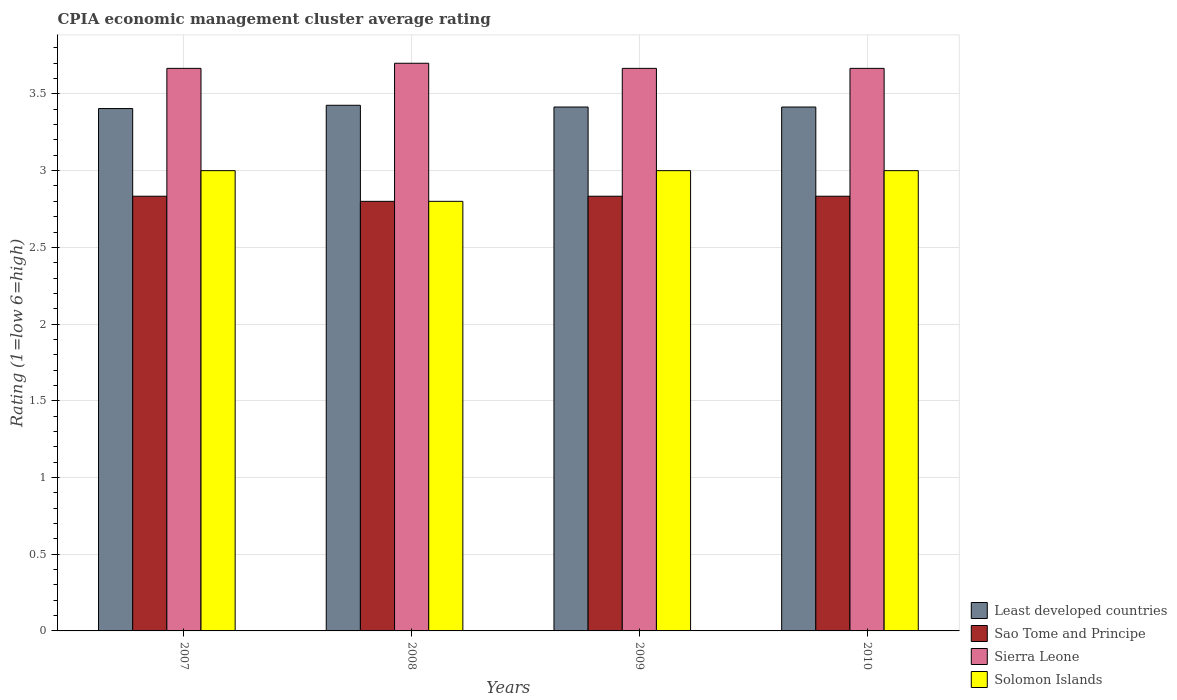Are the number of bars on each tick of the X-axis equal?
Offer a terse response. Yes. How many bars are there on the 3rd tick from the left?
Provide a succinct answer. 4. What is the label of the 1st group of bars from the left?
Ensure brevity in your answer.  2007. What is the CPIA rating in Solomon Islands in 2008?
Your answer should be very brief. 2.8. Across all years, what is the maximum CPIA rating in Solomon Islands?
Keep it short and to the point. 3. Across all years, what is the minimum CPIA rating in Sierra Leone?
Keep it short and to the point. 3.67. What is the total CPIA rating in Solomon Islands in the graph?
Your answer should be very brief. 11.8. What is the difference between the CPIA rating in Solomon Islands in 2008 and that in 2009?
Give a very brief answer. -0.2. What is the difference between the CPIA rating in Sierra Leone in 2008 and the CPIA rating in Solomon Islands in 2009?
Offer a very short reply. 0.7. What is the average CPIA rating in Solomon Islands per year?
Offer a terse response. 2.95. In the year 2007, what is the difference between the CPIA rating in Least developed countries and CPIA rating in Solomon Islands?
Make the answer very short. 0.4. What is the ratio of the CPIA rating in Least developed countries in 2007 to that in 2010?
Your response must be concise. 1. Is the CPIA rating in Sao Tome and Principe in 2009 less than that in 2010?
Give a very brief answer. No. What is the difference between the highest and the second highest CPIA rating in Sao Tome and Principe?
Offer a terse response. 0. What is the difference between the highest and the lowest CPIA rating in Solomon Islands?
Make the answer very short. 0.2. In how many years, is the CPIA rating in Sierra Leone greater than the average CPIA rating in Sierra Leone taken over all years?
Give a very brief answer. 1. Is the sum of the CPIA rating in Sierra Leone in 2008 and 2009 greater than the maximum CPIA rating in Least developed countries across all years?
Give a very brief answer. Yes. Is it the case that in every year, the sum of the CPIA rating in Sierra Leone and CPIA rating in Solomon Islands is greater than the sum of CPIA rating in Least developed countries and CPIA rating in Sao Tome and Principe?
Your answer should be compact. Yes. What does the 2nd bar from the left in 2008 represents?
Provide a succinct answer. Sao Tome and Principe. What does the 2nd bar from the right in 2008 represents?
Offer a very short reply. Sierra Leone. Is it the case that in every year, the sum of the CPIA rating in Solomon Islands and CPIA rating in Least developed countries is greater than the CPIA rating in Sao Tome and Principe?
Provide a short and direct response. Yes. What is the difference between two consecutive major ticks on the Y-axis?
Offer a terse response. 0.5. Does the graph contain any zero values?
Offer a very short reply. No. Does the graph contain grids?
Ensure brevity in your answer.  Yes. Where does the legend appear in the graph?
Your answer should be very brief. Bottom right. How are the legend labels stacked?
Offer a terse response. Vertical. What is the title of the graph?
Your response must be concise. CPIA economic management cluster average rating. What is the Rating (1=low 6=high) in Least developed countries in 2007?
Keep it short and to the point. 3.4. What is the Rating (1=low 6=high) in Sao Tome and Principe in 2007?
Provide a short and direct response. 2.83. What is the Rating (1=low 6=high) of Sierra Leone in 2007?
Make the answer very short. 3.67. What is the Rating (1=low 6=high) of Least developed countries in 2008?
Keep it short and to the point. 3.43. What is the Rating (1=low 6=high) in Sao Tome and Principe in 2008?
Give a very brief answer. 2.8. What is the Rating (1=low 6=high) of Least developed countries in 2009?
Keep it short and to the point. 3.41. What is the Rating (1=low 6=high) in Sao Tome and Principe in 2009?
Your response must be concise. 2.83. What is the Rating (1=low 6=high) in Sierra Leone in 2009?
Ensure brevity in your answer.  3.67. What is the Rating (1=low 6=high) of Least developed countries in 2010?
Your answer should be very brief. 3.41. What is the Rating (1=low 6=high) in Sao Tome and Principe in 2010?
Give a very brief answer. 2.83. What is the Rating (1=low 6=high) of Sierra Leone in 2010?
Your answer should be compact. 3.67. What is the Rating (1=low 6=high) in Solomon Islands in 2010?
Make the answer very short. 3. Across all years, what is the maximum Rating (1=low 6=high) of Least developed countries?
Provide a succinct answer. 3.43. Across all years, what is the maximum Rating (1=low 6=high) of Sao Tome and Principe?
Your answer should be compact. 2.83. Across all years, what is the maximum Rating (1=low 6=high) of Sierra Leone?
Give a very brief answer. 3.7. Across all years, what is the minimum Rating (1=low 6=high) in Least developed countries?
Ensure brevity in your answer.  3.4. Across all years, what is the minimum Rating (1=low 6=high) of Sierra Leone?
Give a very brief answer. 3.67. Across all years, what is the minimum Rating (1=low 6=high) of Solomon Islands?
Ensure brevity in your answer.  2.8. What is the total Rating (1=low 6=high) of Least developed countries in the graph?
Ensure brevity in your answer.  13.66. What is the total Rating (1=low 6=high) of Sao Tome and Principe in the graph?
Ensure brevity in your answer.  11.3. What is the total Rating (1=low 6=high) of Solomon Islands in the graph?
Your answer should be very brief. 11.8. What is the difference between the Rating (1=low 6=high) in Least developed countries in 2007 and that in 2008?
Offer a terse response. -0.02. What is the difference between the Rating (1=low 6=high) of Sierra Leone in 2007 and that in 2008?
Provide a succinct answer. -0.03. What is the difference between the Rating (1=low 6=high) in Least developed countries in 2007 and that in 2009?
Give a very brief answer. -0.01. What is the difference between the Rating (1=low 6=high) in Sao Tome and Principe in 2007 and that in 2009?
Your answer should be compact. 0. What is the difference between the Rating (1=low 6=high) in Solomon Islands in 2007 and that in 2009?
Ensure brevity in your answer.  0. What is the difference between the Rating (1=low 6=high) of Least developed countries in 2007 and that in 2010?
Give a very brief answer. -0.01. What is the difference between the Rating (1=low 6=high) of Sao Tome and Principe in 2007 and that in 2010?
Provide a short and direct response. 0. What is the difference between the Rating (1=low 6=high) of Solomon Islands in 2007 and that in 2010?
Offer a very short reply. 0. What is the difference between the Rating (1=low 6=high) of Least developed countries in 2008 and that in 2009?
Your answer should be very brief. 0.01. What is the difference between the Rating (1=low 6=high) in Sao Tome and Principe in 2008 and that in 2009?
Keep it short and to the point. -0.03. What is the difference between the Rating (1=low 6=high) of Solomon Islands in 2008 and that in 2009?
Provide a short and direct response. -0.2. What is the difference between the Rating (1=low 6=high) in Least developed countries in 2008 and that in 2010?
Your response must be concise. 0.01. What is the difference between the Rating (1=low 6=high) in Sao Tome and Principe in 2008 and that in 2010?
Provide a succinct answer. -0.03. What is the difference between the Rating (1=low 6=high) of Sierra Leone in 2008 and that in 2010?
Keep it short and to the point. 0.03. What is the difference between the Rating (1=low 6=high) of Least developed countries in 2009 and that in 2010?
Ensure brevity in your answer.  0. What is the difference between the Rating (1=low 6=high) in Sierra Leone in 2009 and that in 2010?
Make the answer very short. 0. What is the difference between the Rating (1=low 6=high) of Solomon Islands in 2009 and that in 2010?
Your response must be concise. 0. What is the difference between the Rating (1=low 6=high) of Least developed countries in 2007 and the Rating (1=low 6=high) of Sao Tome and Principe in 2008?
Your answer should be compact. 0.6. What is the difference between the Rating (1=low 6=high) of Least developed countries in 2007 and the Rating (1=low 6=high) of Sierra Leone in 2008?
Ensure brevity in your answer.  -0.3. What is the difference between the Rating (1=low 6=high) of Least developed countries in 2007 and the Rating (1=low 6=high) of Solomon Islands in 2008?
Your answer should be very brief. 0.6. What is the difference between the Rating (1=low 6=high) of Sao Tome and Principe in 2007 and the Rating (1=low 6=high) of Sierra Leone in 2008?
Offer a very short reply. -0.87. What is the difference between the Rating (1=low 6=high) of Sierra Leone in 2007 and the Rating (1=low 6=high) of Solomon Islands in 2008?
Offer a terse response. 0.87. What is the difference between the Rating (1=low 6=high) in Least developed countries in 2007 and the Rating (1=low 6=high) in Sao Tome and Principe in 2009?
Make the answer very short. 0.57. What is the difference between the Rating (1=low 6=high) of Least developed countries in 2007 and the Rating (1=low 6=high) of Sierra Leone in 2009?
Give a very brief answer. -0.26. What is the difference between the Rating (1=low 6=high) of Least developed countries in 2007 and the Rating (1=low 6=high) of Solomon Islands in 2009?
Your answer should be compact. 0.4. What is the difference between the Rating (1=low 6=high) of Sao Tome and Principe in 2007 and the Rating (1=low 6=high) of Sierra Leone in 2009?
Your response must be concise. -0.83. What is the difference between the Rating (1=low 6=high) of Least developed countries in 2007 and the Rating (1=low 6=high) of Sierra Leone in 2010?
Your response must be concise. -0.26. What is the difference between the Rating (1=low 6=high) in Least developed countries in 2007 and the Rating (1=low 6=high) in Solomon Islands in 2010?
Keep it short and to the point. 0.4. What is the difference between the Rating (1=low 6=high) of Sao Tome and Principe in 2007 and the Rating (1=low 6=high) of Sierra Leone in 2010?
Make the answer very short. -0.83. What is the difference between the Rating (1=low 6=high) of Sao Tome and Principe in 2007 and the Rating (1=low 6=high) of Solomon Islands in 2010?
Keep it short and to the point. -0.17. What is the difference between the Rating (1=low 6=high) in Sierra Leone in 2007 and the Rating (1=low 6=high) in Solomon Islands in 2010?
Provide a short and direct response. 0.67. What is the difference between the Rating (1=low 6=high) in Least developed countries in 2008 and the Rating (1=low 6=high) in Sao Tome and Principe in 2009?
Ensure brevity in your answer.  0.59. What is the difference between the Rating (1=low 6=high) in Least developed countries in 2008 and the Rating (1=low 6=high) in Sierra Leone in 2009?
Give a very brief answer. -0.24. What is the difference between the Rating (1=low 6=high) of Least developed countries in 2008 and the Rating (1=low 6=high) of Solomon Islands in 2009?
Provide a short and direct response. 0.43. What is the difference between the Rating (1=low 6=high) of Sao Tome and Principe in 2008 and the Rating (1=low 6=high) of Sierra Leone in 2009?
Keep it short and to the point. -0.87. What is the difference between the Rating (1=low 6=high) in Least developed countries in 2008 and the Rating (1=low 6=high) in Sao Tome and Principe in 2010?
Offer a very short reply. 0.59. What is the difference between the Rating (1=low 6=high) of Least developed countries in 2008 and the Rating (1=low 6=high) of Sierra Leone in 2010?
Make the answer very short. -0.24. What is the difference between the Rating (1=low 6=high) of Least developed countries in 2008 and the Rating (1=low 6=high) of Solomon Islands in 2010?
Your response must be concise. 0.43. What is the difference between the Rating (1=low 6=high) of Sao Tome and Principe in 2008 and the Rating (1=low 6=high) of Sierra Leone in 2010?
Offer a terse response. -0.87. What is the difference between the Rating (1=low 6=high) of Least developed countries in 2009 and the Rating (1=low 6=high) of Sao Tome and Principe in 2010?
Ensure brevity in your answer.  0.58. What is the difference between the Rating (1=low 6=high) in Least developed countries in 2009 and the Rating (1=low 6=high) in Sierra Leone in 2010?
Your answer should be very brief. -0.25. What is the difference between the Rating (1=low 6=high) of Least developed countries in 2009 and the Rating (1=low 6=high) of Solomon Islands in 2010?
Keep it short and to the point. 0.41. What is the difference between the Rating (1=low 6=high) of Sao Tome and Principe in 2009 and the Rating (1=low 6=high) of Solomon Islands in 2010?
Give a very brief answer. -0.17. What is the difference between the Rating (1=low 6=high) of Sierra Leone in 2009 and the Rating (1=low 6=high) of Solomon Islands in 2010?
Keep it short and to the point. 0.67. What is the average Rating (1=low 6=high) of Least developed countries per year?
Offer a terse response. 3.42. What is the average Rating (1=low 6=high) in Sao Tome and Principe per year?
Provide a succinct answer. 2.83. What is the average Rating (1=low 6=high) of Sierra Leone per year?
Your answer should be compact. 3.67. What is the average Rating (1=low 6=high) of Solomon Islands per year?
Offer a very short reply. 2.95. In the year 2007, what is the difference between the Rating (1=low 6=high) in Least developed countries and Rating (1=low 6=high) in Sierra Leone?
Your answer should be compact. -0.26. In the year 2007, what is the difference between the Rating (1=low 6=high) of Least developed countries and Rating (1=low 6=high) of Solomon Islands?
Ensure brevity in your answer.  0.4. In the year 2007, what is the difference between the Rating (1=low 6=high) of Sao Tome and Principe and Rating (1=low 6=high) of Sierra Leone?
Your answer should be compact. -0.83. In the year 2008, what is the difference between the Rating (1=low 6=high) of Least developed countries and Rating (1=low 6=high) of Sao Tome and Principe?
Make the answer very short. 0.63. In the year 2008, what is the difference between the Rating (1=low 6=high) of Least developed countries and Rating (1=low 6=high) of Sierra Leone?
Keep it short and to the point. -0.27. In the year 2008, what is the difference between the Rating (1=low 6=high) in Least developed countries and Rating (1=low 6=high) in Solomon Islands?
Offer a terse response. 0.63. In the year 2008, what is the difference between the Rating (1=low 6=high) in Sao Tome and Principe and Rating (1=low 6=high) in Sierra Leone?
Make the answer very short. -0.9. In the year 2008, what is the difference between the Rating (1=low 6=high) in Sao Tome and Principe and Rating (1=low 6=high) in Solomon Islands?
Provide a succinct answer. 0. In the year 2008, what is the difference between the Rating (1=low 6=high) of Sierra Leone and Rating (1=low 6=high) of Solomon Islands?
Provide a short and direct response. 0.9. In the year 2009, what is the difference between the Rating (1=low 6=high) of Least developed countries and Rating (1=low 6=high) of Sao Tome and Principe?
Give a very brief answer. 0.58. In the year 2009, what is the difference between the Rating (1=low 6=high) of Least developed countries and Rating (1=low 6=high) of Sierra Leone?
Make the answer very short. -0.25. In the year 2009, what is the difference between the Rating (1=low 6=high) in Least developed countries and Rating (1=low 6=high) in Solomon Islands?
Offer a very short reply. 0.41. In the year 2010, what is the difference between the Rating (1=low 6=high) of Least developed countries and Rating (1=low 6=high) of Sao Tome and Principe?
Your answer should be very brief. 0.58. In the year 2010, what is the difference between the Rating (1=low 6=high) of Least developed countries and Rating (1=low 6=high) of Sierra Leone?
Your answer should be very brief. -0.25. In the year 2010, what is the difference between the Rating (1=low 6=high) in Least developed countries and Rating (1=low 6=high) in Solomon Islands?
Offer a very short reply. 0.41. In the year 2010, what is the difference between the Rating (1=low 6=high) of Sao Tome and Principe and Rating (1=low 6=high) of Solomon Islands?
Your response must be concise. -0.17. What is the ratio of the Rating (1=low 6=high) of Sao Tome and Principe in 2007 to that in 2008?
Give a very brief answer. 1.01. What is the ratio of the Rating (1=low 6=high) of Solomon Islands in 2007 to that in 2008?
Give a very brief answer. 1.07. What is the ratio of the Rating (1=low 6=high) in Least developed countries in 2007 to that in 2009?
Your answer should be very brief. 1. What is the ratio of the Rating (1=low 6=high) in Sao Tome and Principe in 2007 to that in 2009?
Provide a succinct answer. 1. What is the ratio of the Rating (1=low 6=high) of Solomon Islands in 2007 to that in 2009?
Give a very brief answer. 1. What is the ratio of the Rating (1=low 6=high) of Sao Tome and Principe in 2007 to that in 2010?
Your answer should be compact. 1. What is the ratio of the Rating (1=low 6=high) in Sierra Leone in 2007 to that in 2010?
Your response must be concise. 1. What is the ratio of the Rating (1=low 6=high) of Least developed countries in 2008 to that in 2009?
Ensure brevity in your answer.  1. What is the ratio of the Rating (1=low 6=high) of Sao Tome and Principe in 2008 to that in 2009?
Your answer should be very brief. 0.99. What is the ratio of the Rating (1=low 6=high) of Sierra Leone in 2008 to that in 2009?
Provide a short and direct response. 1.01. What is the ratio of the Rating (1=low 6=high) in Least developed countries in 2008 to that in 2010?
Provide a succinct answer. 1. What is the ratio of the Rating (1=low 6=high) of Sierra Leone in 2008 to that in 2010?
Your answer should be very brief. 1.01. What is the ratio of the Rating (1=low 6=high) in Solomon Islands in 2008 to that in 2010?
Your response must be concise. 0.93. What is the ratio of the Rating (1=low 6=high) in Least developed countries in 2009 to that in 2010?
Offer a terse response. 1. What is the ratio of the Rating (1=low 6=high) in Sierra Leone in 2009 to that in 2010?
Offer a terse response. 1. What is the ratio of the Rating (1=low 6=high) of Solomon Islands in 2009 to that in 2010?
Give a very brief answer. 1. What is the difference between the highest and the second highest Rating (1=low 6=high) of Least developed countries?
Your response must be concise. 0.01. What is the difference between the highest and the second highest Rating (1=low 6=high) of Sao Tome and Principe?
Ensure brevity in your answer.  0. What is the difference between the highest and the second highest Rating (1=low 6=high) of Sierra Leone?
Your response must be concise. 0.03. What is the difference between the highest and the second highest Rating (1=low 6=high) in Solomon Islands?
Provide a succinct answer. 0. What is the difference between the highest and the lowest Rating (1=low 6=high) of Least developed countries?
Keep it short and to the point. 0.02. What is the difference between the highest and the lowest Rating (1=low 6=high) of Sao Tome and Principe?
Your answer should be very brief. 0.03. What is the difference between the highest and the lowest Rating (1=low 6=high) in Sierra Leone?
Offer a very short reply. 0.03. What is the difference between the highest and the lowest Rating (1=low 6=high) in Solomon Islands?
Offer a very short reply. 0.2. 